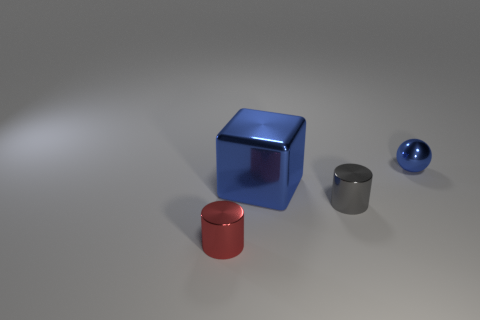Subtract all brown cylinders. Subtract all cyan blocks. How many cylinders are left? 2 Add 4 red matte objects. How many objects exist? 8 Subtract all balls. How many objects are left? 3 Add 3 red shiny cylinders. How many red shiny cylinders are left? 4 Add 2 metal spheres. How many metal spheres exist? 3 Subtract 0 red blocks. How many objects are left? 4 Subtract all blue metallic spheres. Subtract all tiny blue metal balls. How many objects are left? 2 